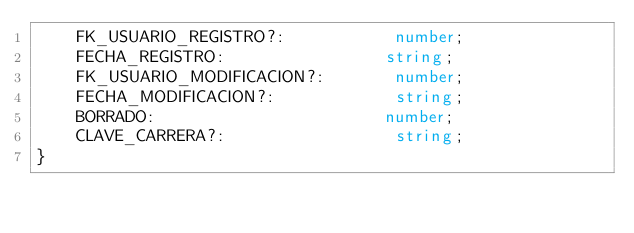<code> <loc_0><loc_0><loc_500><loc_500><_TypeScript_>    FK_USUARIO_REGISTRO?:           number;
    FECHA_REGISTRO:                string;
    FK_USUARIO_MODIFICACION?:       number;
    FECHA_MODIFICACION?:            string;
    BORRADO:                       number;
    CLAVE_CARRERA?:                 string;
}
</code> 